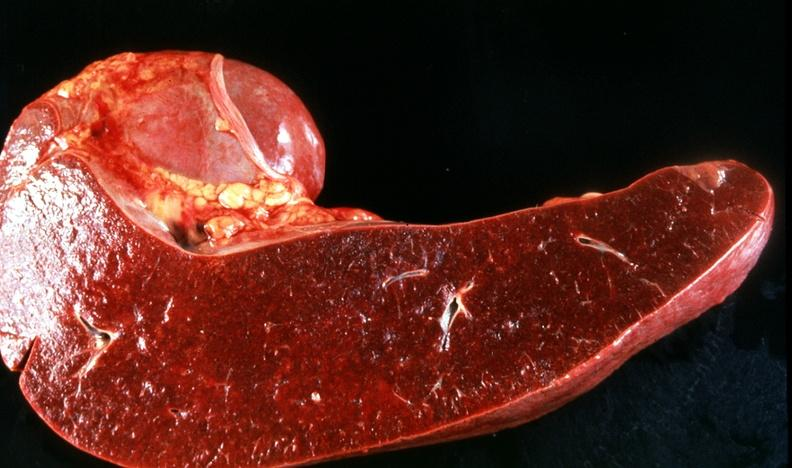does bone, mandible show spleen, congestion, congestive heart failure?
Answer the question using a single word or phrase. No 